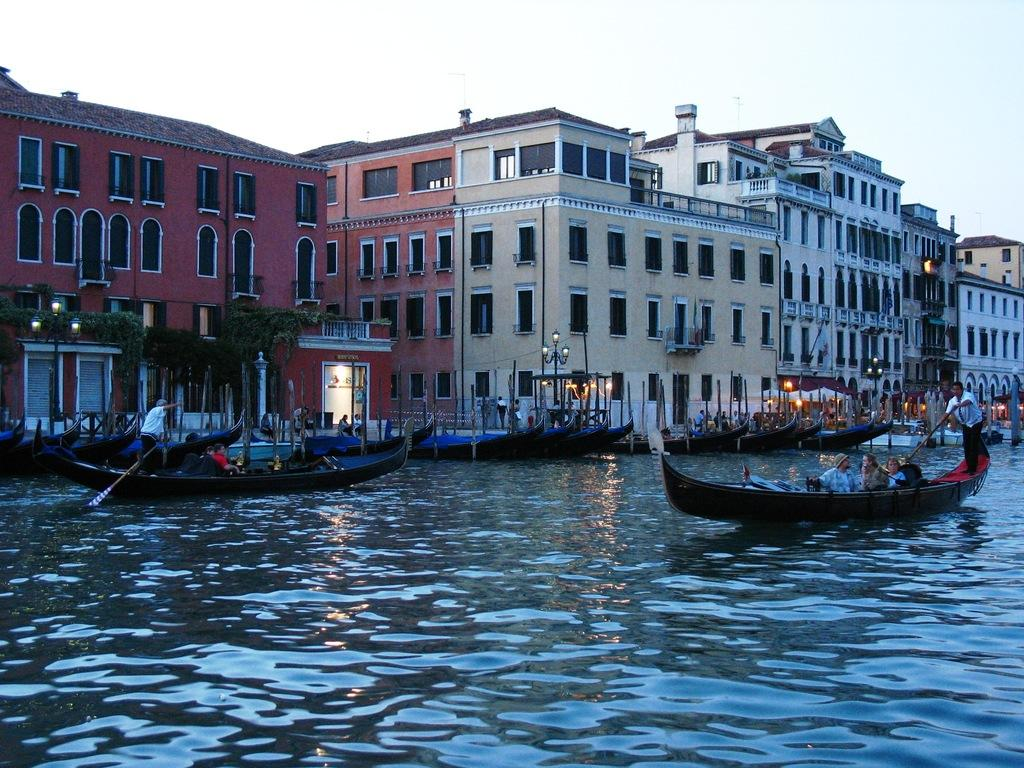What is the main subject in the center of the image? There are buildings in the center of the image. What can be seen at the bottom of the image? There are boats on the water at the bottom of the image. What are the people in the boats doing? People are sitting in the boats. What is visible at the top of the image? There is sky visible at the top of the image. What type of bone can be seen in the image? There is no bone present in the image. What time of day is it in the image, considering the harmony of the scene? The time of day cannot be determined from the image, and the concept of harmony is subjective and not directly related to the image. 